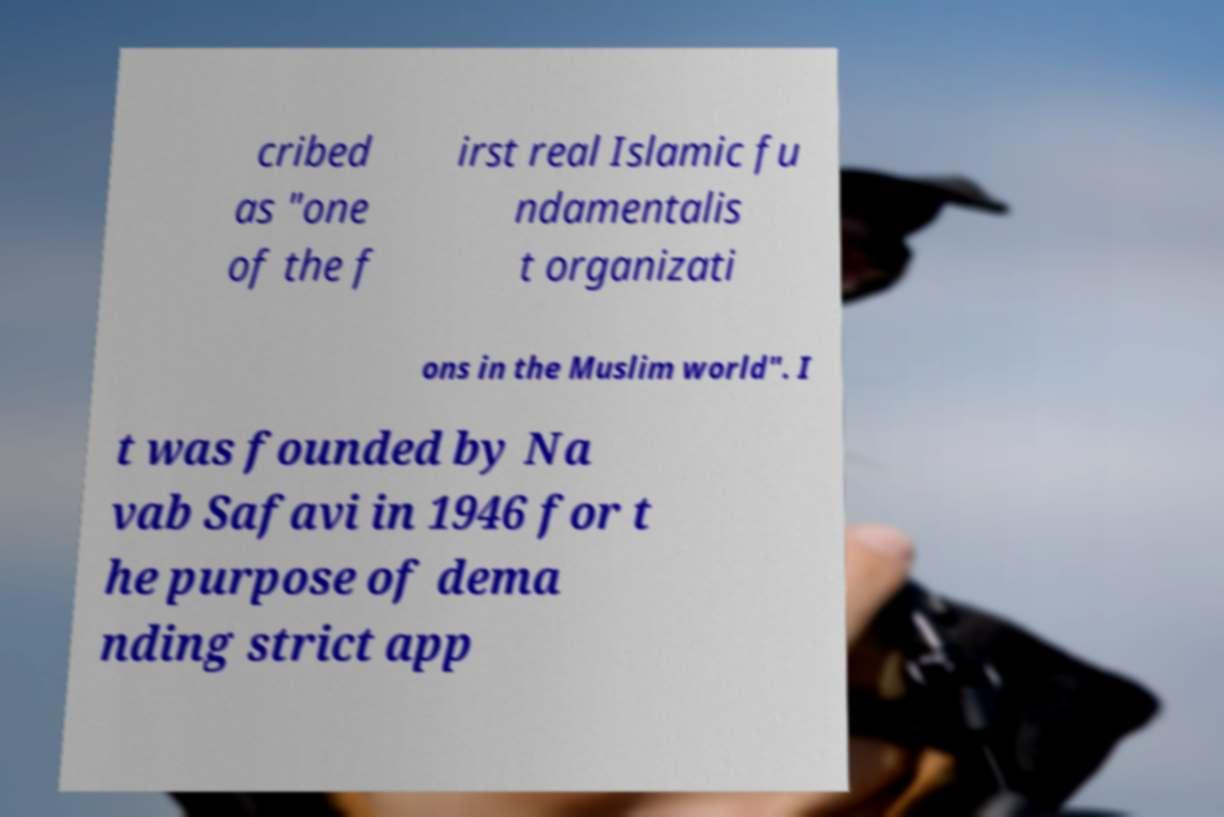What messages or text are displayed in this image? I need them in a readable, typed format. cribed as "one of the f irst real Islamic fu ndamentalis t organizati ons in the Muslim world". I t was founded by Na vab Safavi in 1946 for t he purpose of dema nding strict app 